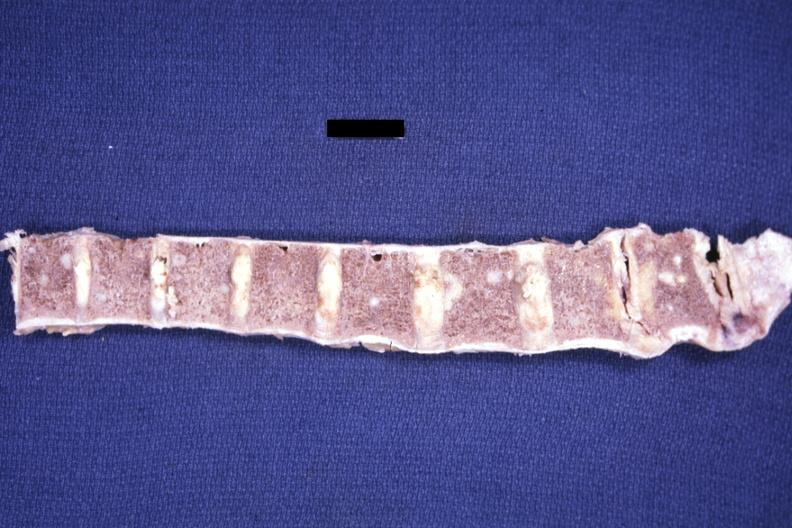what is present?
Answer the question using a single word or phrase. Joints 